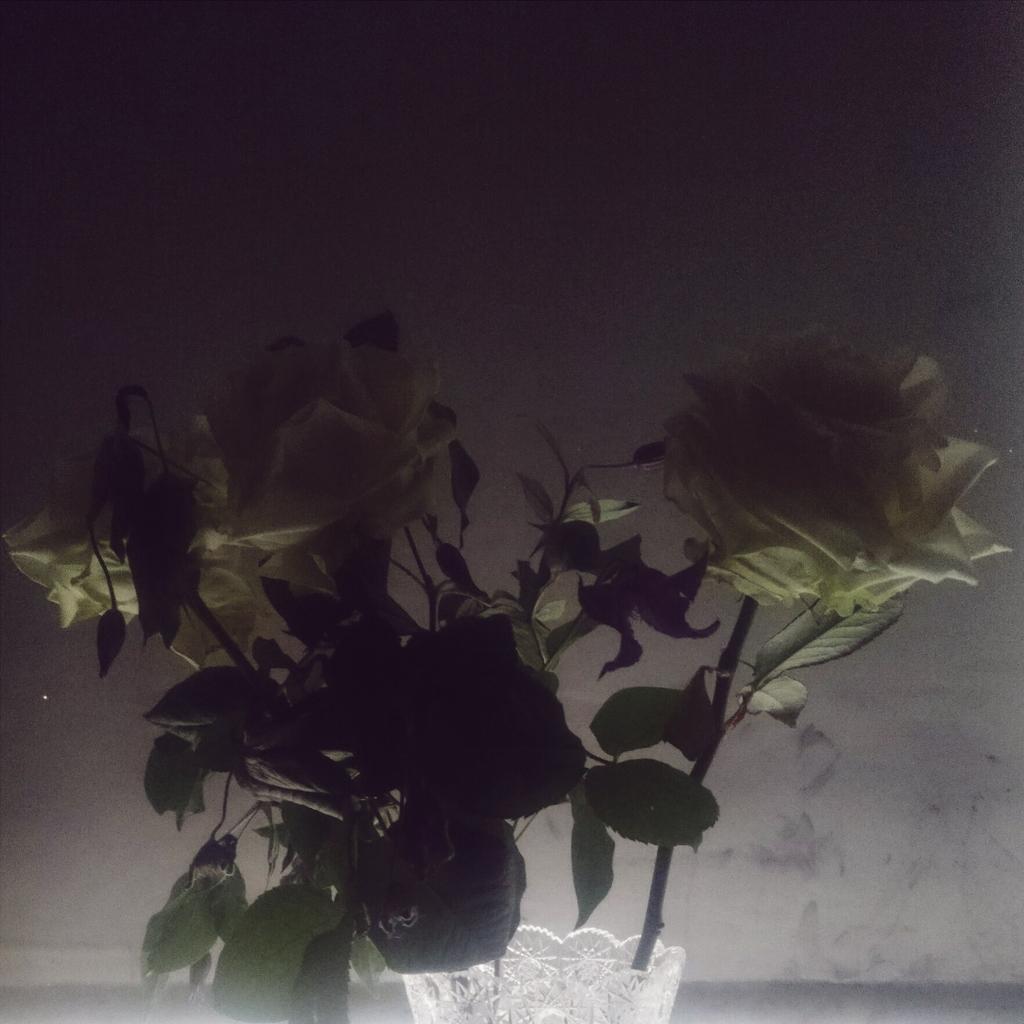Could you give a brief overview of what you see in this image? In the center of the image we can see flowers to the plant. In the background there is wall. 